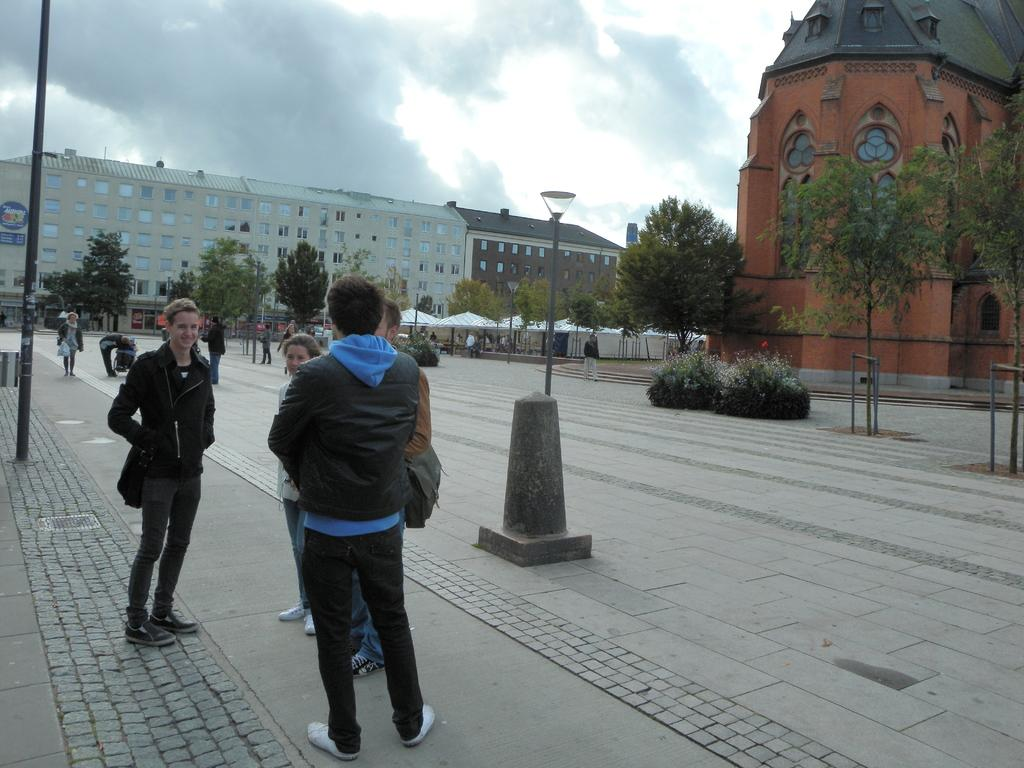How many people are in the image? There are people in the image, but the exact number is not specified. What structures can be seen in the image? There are light poles, trees, plants, buildings, and a board on a wall in the image. What architectural features are present in the image? Windows are present in the image. What is the condition of the sky in the image? The sky is visible in the image and appears to be cloudy. Can you tell me how many boys are standing near the board in the image? There is no mention of a boy or boys in the image; only people are mentioned. Is the board hot to the touch in the image? The image does not provide any information about the temperature of the board or any other objects. 